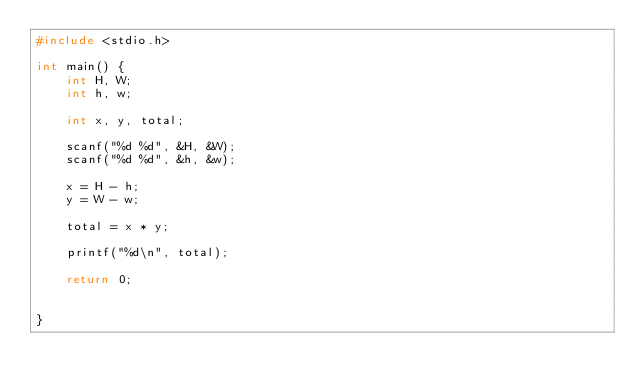Convert code to text. <code><loc_0><loc_0><loc_500><loc_500><_C_>#include <stdio.h>

int main() {
	int H, W;
	int h, w;
	
	int x, y, total;

	scanf("%d %d", &H, &W);
	scanf("%d %d", &h, &w);

	x = H - h;
	y = W - w;

	total = x * y;

	printf("%d\n", total);

	return 0;


}</code> 